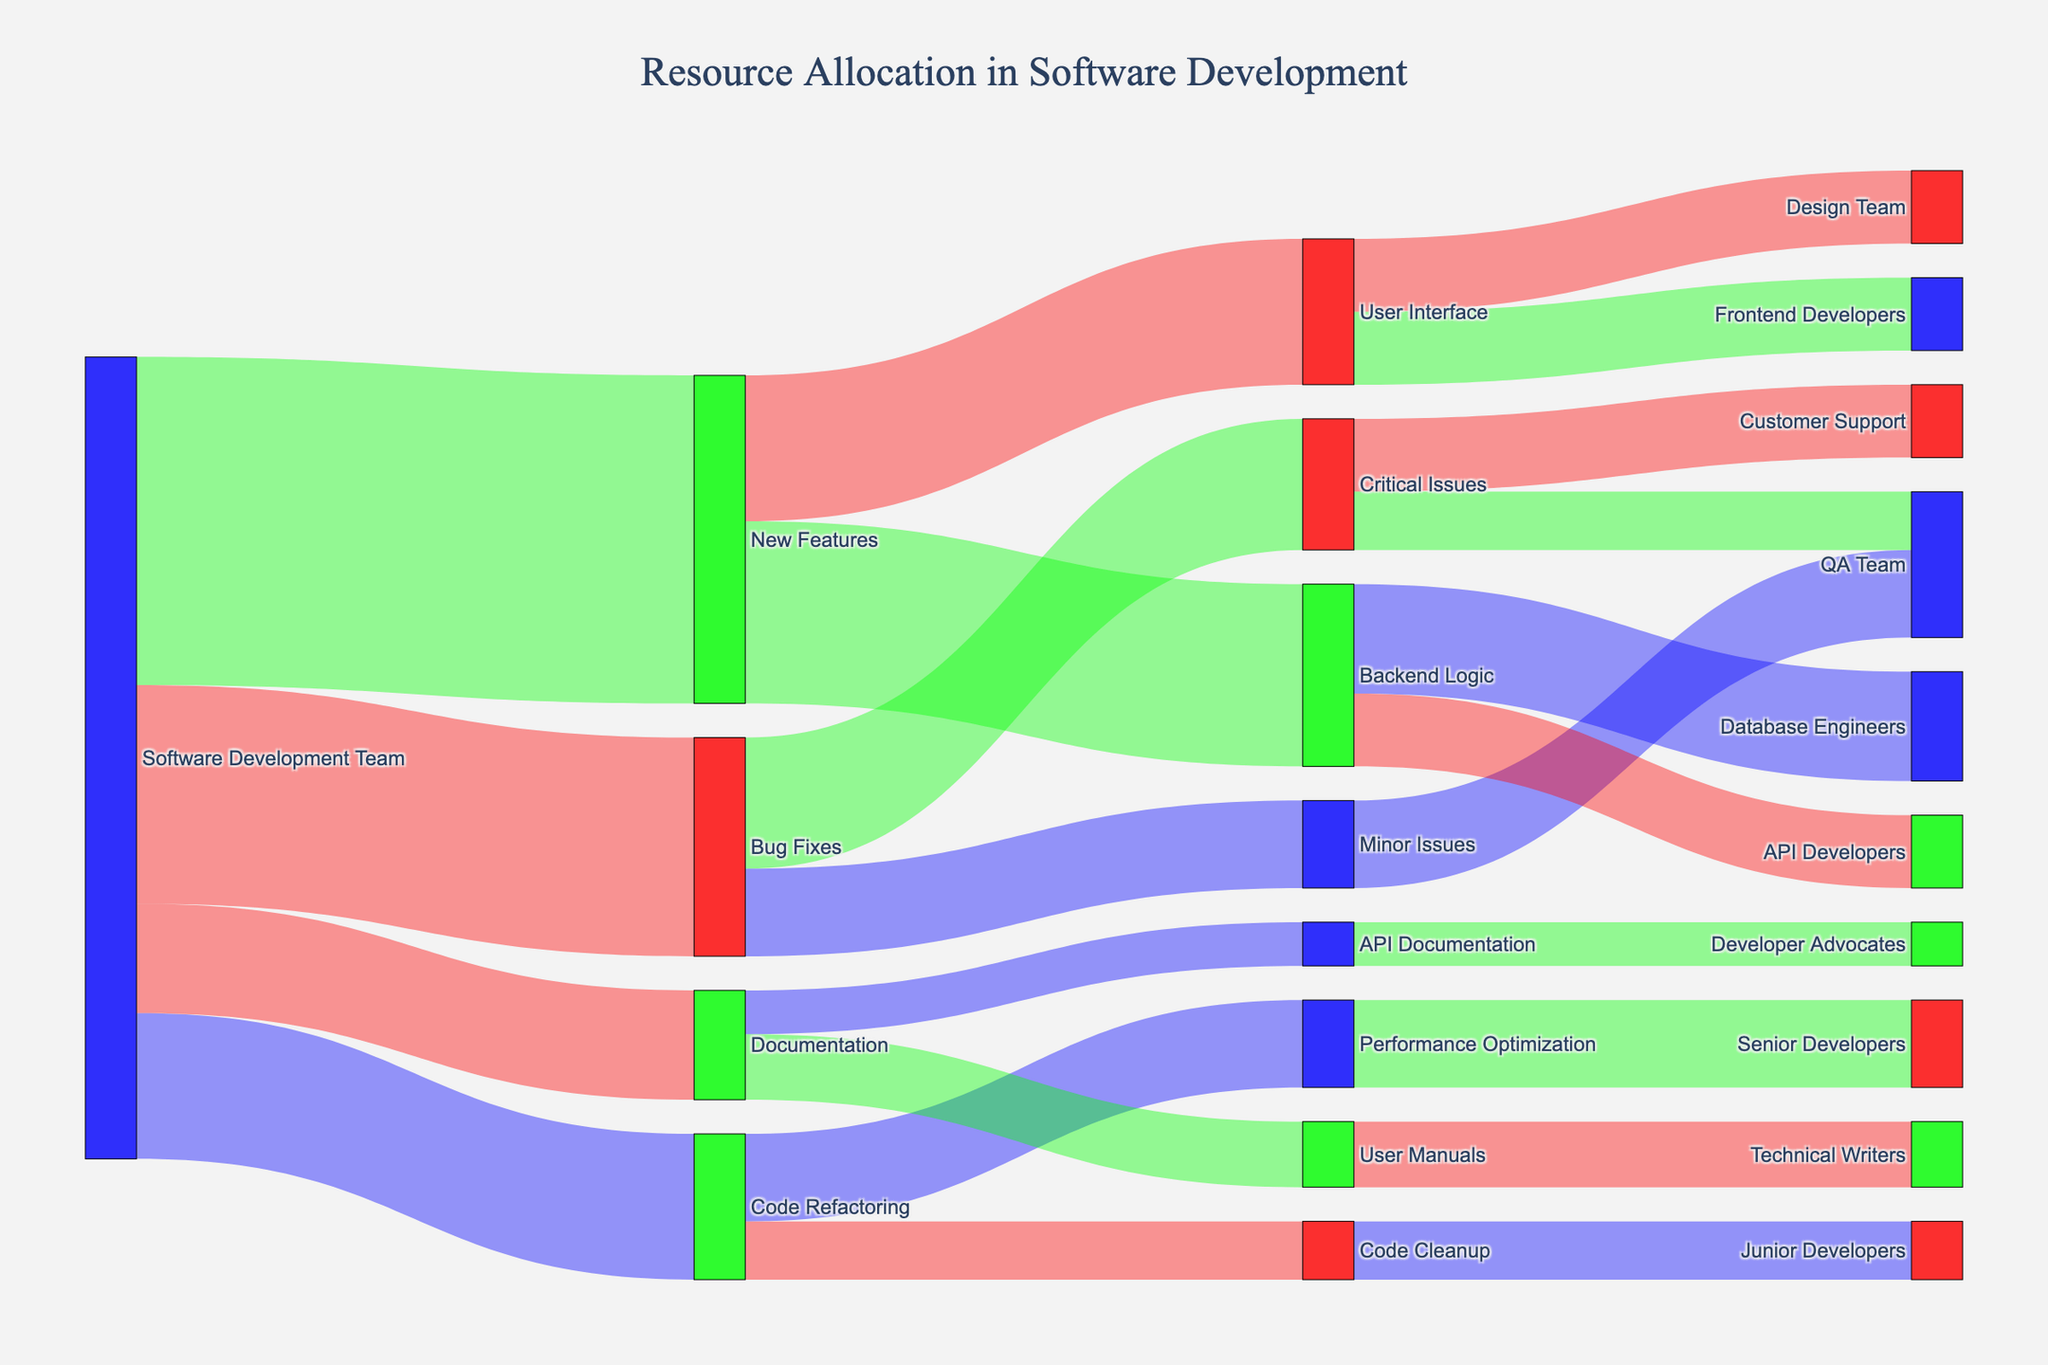What is the title of the Sankey Diagram? The title of the diagram is usually displayed at the top center. In this case, the title is mentioned in the code that updates the layout.
Answer: Resource Allocation in Software Development What task does the Software Development Team spend the most time on? To find this, look at the links originating from the "Software Development Team" node and identify the widest link. The link with the largest value indicates the most time spent on that task.
Answer: New Features How much time is spent on Code Refactoring? Find the link from "Software Development Team" to "Code Refactoring" and read the value associated with it.
Answer: 200 Which specific area under Bug Fixes takes up the most time? Look at the sub-links under "Bug Fixes" and find which one has the greatest value. Compare the values for "Critical Issues" and "Minor Issues".
Answer: Critical Issues What is the total time allocated to Documentation? Sum the values for "User Manuals" and "API Documentation" linked from "Documentation".
Answer: 150 How does the time spent on User Interface development compare to Backend Logic development? Compare the values of the links from "New Features" to "User Interface" and "Backend Logic".
Answer: Backend Logic has more time allocated What tasks are the Backend Logic divided into and how much time is allocated to each? Look at the sub-links under "Backend Logic" to identify what it is divided into and the values associated with each link.
Answer: Database Engineers: 150, API Developers: 100 Which team spends time on Critical Issues? Find the node "Critical Issues" and identify the target nodes connected to it, then read the labels of those nodes.
Answer: Customer Support and QA Team How much time is allocated to Performance Optimization under Code Refactoring? Locate the link from "Code Refactoring" to "Performance Optimization" and take note of the value.
Answer: 120 Which task has the least time allocated to it? To determine this, examine all the values in the diagram and identify the smallest one.
Answer: API Documentation 